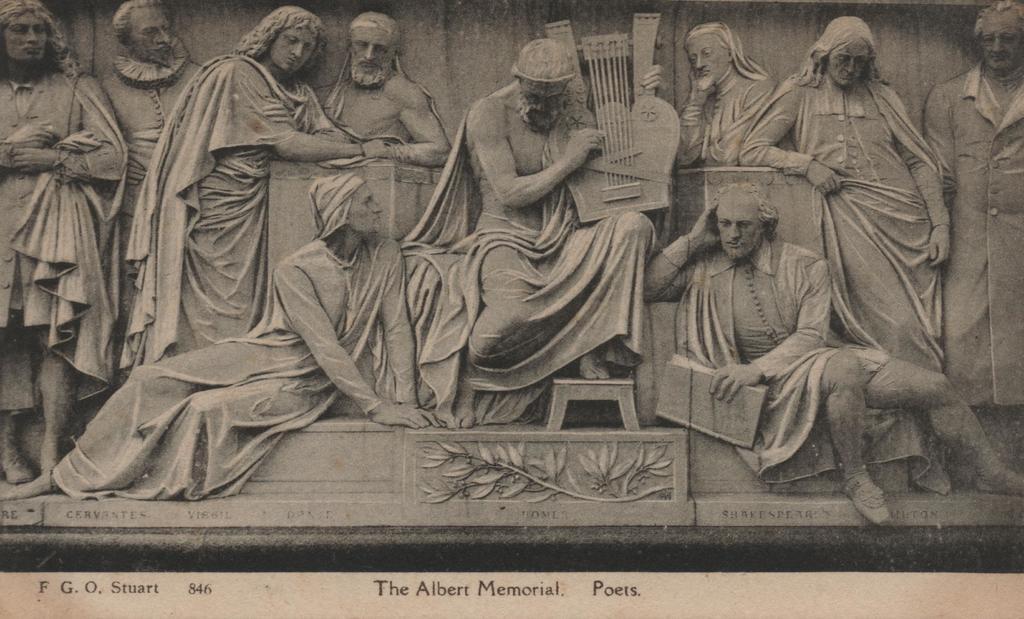How would you summarize this image in a sentence or two? In this picture there is a sculpture of few persons and there is something written below it. 